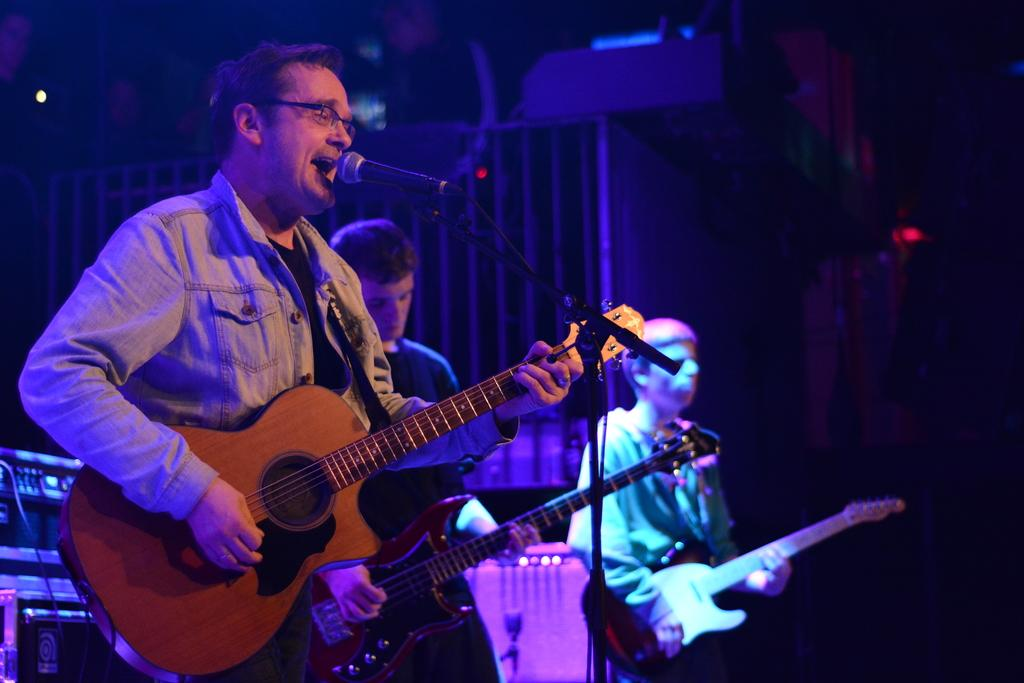How many people are in the image? There are three men in the image. What are the men doing in the image? The men are singing and playing guitars. What can be seen in front of the men in the image? The men are standing in front of a microphone. What is the color of the background in the image? The background of the image is dark. Can you tell me how many kittens are playing on the floor in the image? There are no kittens or floors present in the image; it features three men singing and playing guitars in front of a microphone with a dark background. 